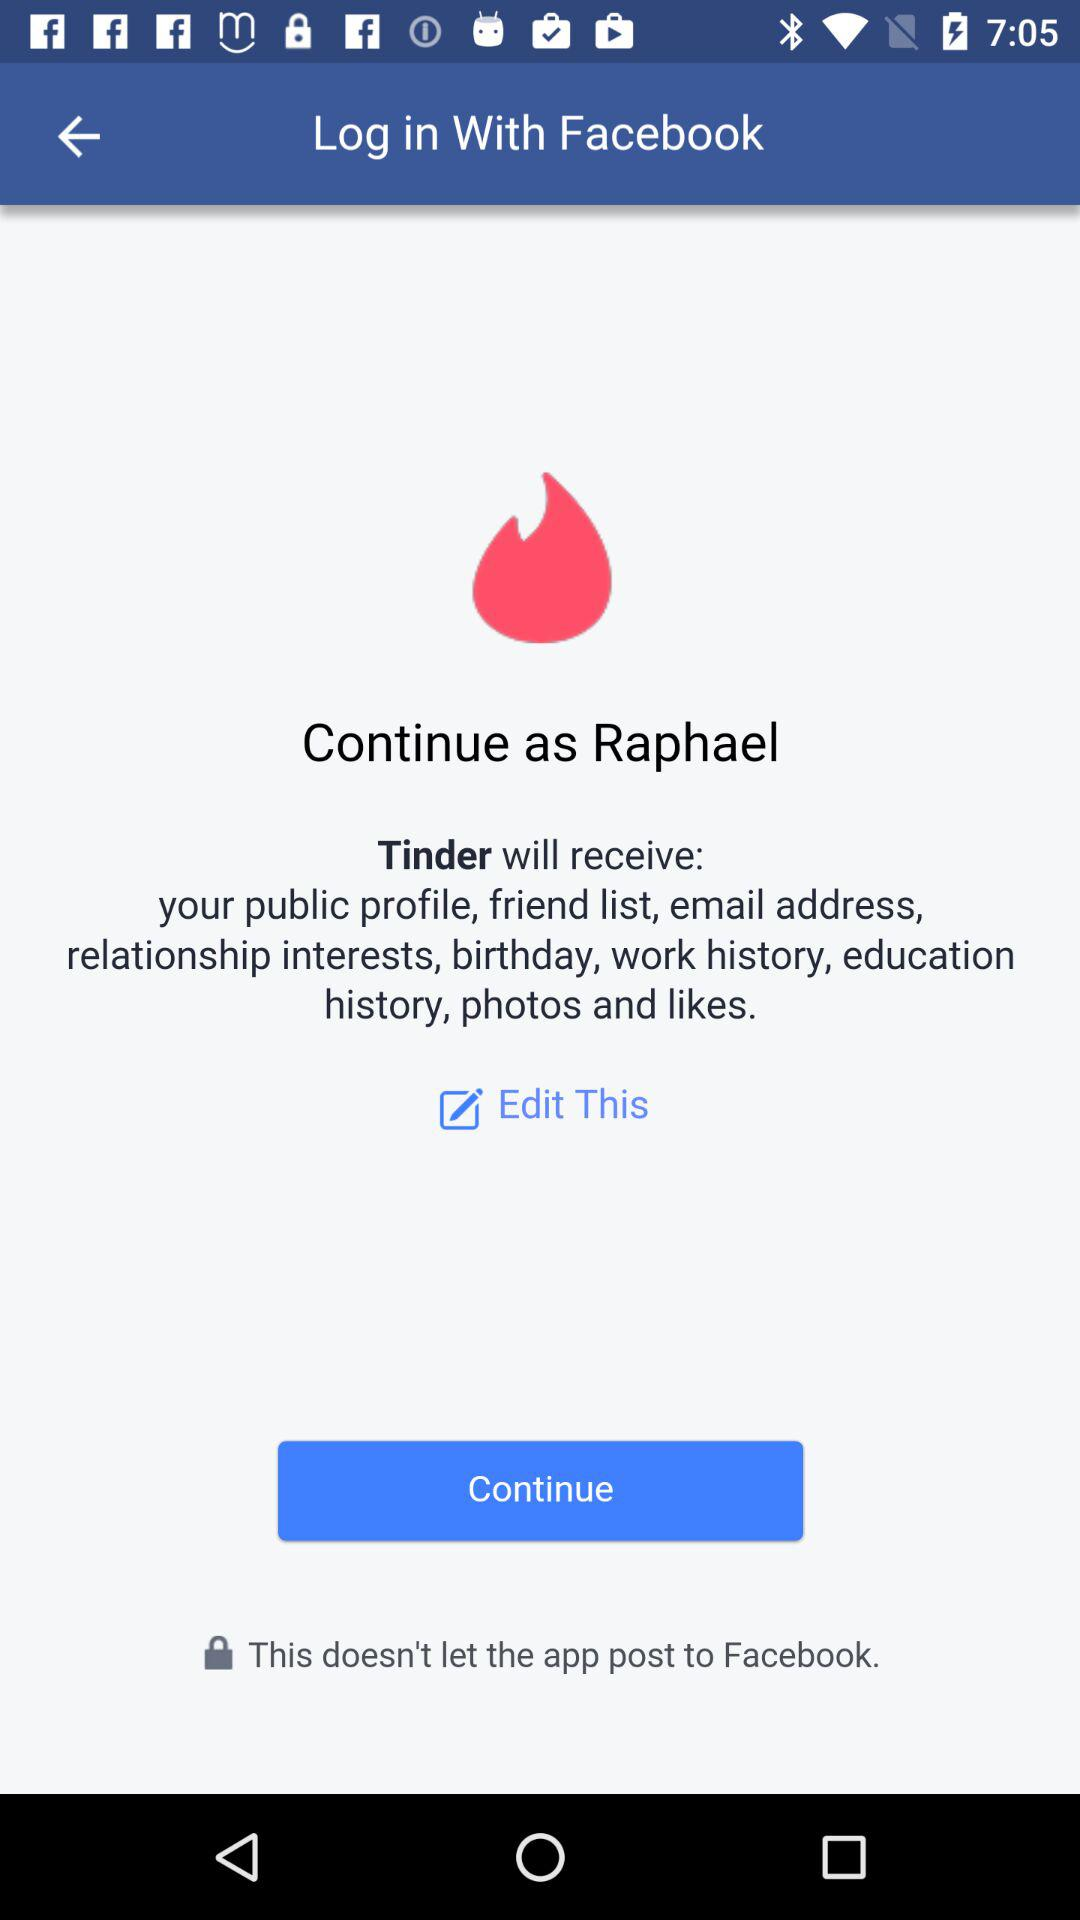What is the user name? The user name is Raphael. 